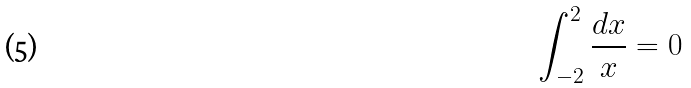Convert formula to latex. <formula><loc_0><loc_0><loc_500><loc_500>\int _ { - 2 } ^ { 2 } \frac { d x } { x } = 0</formula> 